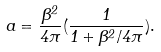Convert formula to latex. <formula><loc_0><loc_0><loc_500><loc_500>a = \frac { \beta ^ { 2 } } { 4 \pi } ( \frac { 1 } { 1 + \beta ^ { 2 } / 4 \pi } ) .</formula> 